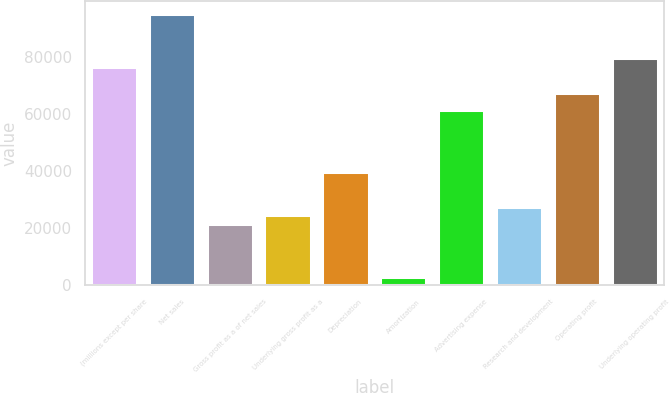Convert chart to OTSL. <chart><loc_0><loc_0><loc_500><loc_500><bar_chart><fcel>(millions except per share<fcel>Net sales<fcel>Gross profit as a of net sales<fcel>Underlying gross profit as a<fcel>Depreciation<fcel>Amortization<fcel>Advertising expense<fcel>Research and development<fcel>Operating profit<fcel>Underlying operating profit<nl><fcel>76674.9<fcel>95076.5<fcel>21470.2<fcel>24537.1<fcel>39871.8<fcel>3068.6<fcel>61340.3<fcel>27604<fcel>67474.1<fcel>79741.9<nl></chart> 